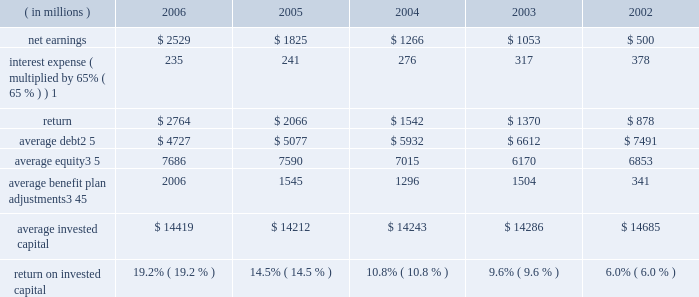Notes to five year summary ( a ) includes the effects of items not considered in the assessment of the operating performance of our business segments ( see the section , 201cresults of operations 2013 unallocated corporate ( expense ) income , net 201d in management 2019s discussion and analysis of financial condition and results of operations ( md&a ) ) which , on a combined basis , increased earnings from continuing operations before income taxes by $ 214 million , $ 139 million after tax ( $ 0.31 per share ) .
Also includes a reduction in income tax expense of $ 62 million ( $ 0.14 per share ) resulting from a tax benefit related to claims we filed for additional extraterritorial income exclusion ( eti ) tax benefits .
These items increased earnings by $ 201 million after tax ( $ 0.45 per share ) .
( b ) includes the effects of items not considered in the assessment of the operating performance of our business segments ( see the section , 201cresults of operations 2013 unallocated corporate ( expense ) income , net 201d in md&a ) which , on a combined basis , increased earnings from continuing operations before income taxes by $ 173 million , $ 113 million after tax ( $ 0.25 per share ) .
( c ) includes the effects of items not considered in the assessment of the operating performance of our business segments ( see the section , 201cresults of operations 2013 unallocated corporate ( expense ) income , net 201d in md&a ) which , on a combined basis , decreased earnings from continuing operations before income taxes by $ 215 million , $ 154 million after tax ( $ 0.34 per share ) .
Also includes a reduction in income tax expense resulting from the closure of an internal revenue service examination of $ 144 million ( $ 0.32 per share ) .
These items reduced earnings by $ 10 million after tax ( $ 0.02 per share ) .
( d ) includes the effects of items not considered in the assessment of the operating performance of our business segments which , on a combined basis , decreased earnings from continuing operations before income taxes by $ 153 million , $ 102 million after tax ( $ 0.22 per share ) .
( e ) includes the effects of items not considered in the assessment of the operating performance of our business segments which , on a combined basis , decreased earnings from continuing operations before income taxes by $ 1112 million , $ 632 million after tax ( $ 1.40 per share ) .
( f ) we define return on invested capital ( roic ) as net earnings plus after-tax interest expense divided by average invested capital ( stockholders 2019 equity plus debt ) , after adjusting stockholders 2019 equity by adding back adjustments related to postretirement benefit plans .
We believe that reporting roic provides investors with greater visibility into how effectively we use the capital invested in our operations .
We use roic to evaluate multi-year investment decisions and as a long-term performance measure , and also use it as a factor in evaluating management performance under certain of our incentive compensation plans .
Roic is not a measure of financial performance under gaap , and may not be defined and calculated by other companies in the same manner .
Roic should not be considered in isolation or as an alternative to net earnings as an indicator of performance .
We calculate roic as follows : ( in millions ) 2006 2005 2004 2003 2002 .
1 represents after-tax interest expense utilizing the federal statutory rate of 35% ( 35 % ) .
2 debt consists of long-term debt , including current maturities , and short-term borrowings ( if any ) .
3 equity includes non-cash adjustments , primarily for the additional minimum pension liability in all years and the adoption of fas 158 in 2006 .
4 average benefit plan adjustments reflect the cumulative value of entries identified in our statement of stockholders equity under the captions 201cadjustment for adoption of fas 158 201d and 201cminimum pension liability . 201d the annual benefit plan adjustments to equity were : 2006 = ( $ 1883 ) million ; 2005 = ( $ 105 ) million ; 2004 = ( $ 285 ) million ; 2003 = $ 331 million ; and 2002 = ( $ 1537 ) million .
As these entries are recorded in the fourth quarter , the value added back to our average equity in a given year is the cumulative impact of all prior year entries plus 20% ( 20 % ) of the current year entry value .
5 yearly averages are calculated using balances at the start of the year and at the end of each quarter. .
What was the average return on invested capital from 2002 to 2006? 
Computations: table_average(return on invested capital, none)
Answer: 0.1202. Notes to five year summary ( a ) includes the effects of items not considered in the assessment of the operating performance of our business segments ( see the section , 201cresults of operations 2013 unallocated corporate ( expense ) income , net 201d in management 2019s discussion and analysis of financial condition and results of operations ( md&a ) ) which , on a combined basis , increased earnings from continuing operations before income taxes by $ 214 million , $ 139 million after tax ( $ 0.31 per share ) .
Also includes a reduction in income tax expense of $ 62 million ( $ 0.14 per share ) resulting from a tax benefit related to claims we filed for additional extraterritorial income exclusion ( eti ) tax benefits .
These items increased earnings by $ 201 million after tax ( $ 0.45 per share ) .
( b ) includes the effects of items not considered in the assessment of the operating performance of our business segments ( see the section , 201cresults of operations 2013 unallocated corporate ( expense ) income , net 201d in md&a ) which , on a combined basis , increased earnings from continuing operations before income taxes by $ 173 million , $ 113 million after tax ( $ 0.25 per share ) .
( c ) includes the effects of items not considered in the assessment of the operating performance of our business segments ( see the section , 201cresults of operations 2013 unallocated corporate ( expense ) income , net 201d in md&a ) which , on a combined basis , decreased earnings from continuing operations before income taxes by $ 215 million , $ 154 million after tax ( $ 0.34 per share ) .
Also includes a reduction in income tax expense resulting from the closure of an internal revenue service examination of $ 144 million ( $ 0.32 per share ) .
These items reduced earnings by $ 10 million after tax ( $ 0.02 per share ) .
( d ) includes the effects of items not considered in the assessment of the operating performance of our business segments which , on a combined basis , decreased earnings from continuing operations before income taxes by $ 153 million , $ 102 million after tax ( $ 0.22 per share ) .
( e ) includes the effects of items not considered in the assessment of the operating performance of our business segments which , on a combined basis , decreased earnings from continuing operations before income taxes by $ 1112 million , $ 632 million after tax ( $ 1.40 per share ) .
( f ) we define return on invested capital ( roic ) as net earnings plus after-tax interest expense divided by average invested capital ( stockholders 2019 equity plus debt ) , after adjusting stockholders 2019 equity by adding back adjustments related to postretirement benefit plans .
We believe that reporting roic provides investors with greater visibility into how effectively we use the capital invested in our operations .
We use roic to evaluate multi-year investment decisions and as a long-term performance measure , and also use it as a factor in evaluating management performance under certain of our incentive compensation plans .
Roic is not a measure of financial performance under gaap , and may not be defined and calculated by other companies in the same manner .
Roic should not be considered in isolation or as an alternative to net earnings as an indicator of performance .
We calculate roic as follows : ( in millions ) 2006 2005 2004 2003 2002 .
1 represents after-tax interest expense utilizing the federal statutory rate of 35% ( 35 % ) .
2 debt consists of long-term debt , including current maturities , and short-term borrowings ( if any ) .
3 equity includes non-cash adjustments , primarily for the additional minimum pension liability in all years and the adoption of fas 158 in 2006 .
4 average benefit plan adjustments reflect the cumulative value of entries identified in our statement of stockholders equity under the captions 201cadjustment for adoption of fas 158 201d and 201cminimum pension liability . 201d the annual benefit plan adjustments to equity were : 2006 = ( $ 1883 ) million ; 2005 = ( $ 105 ) million ; 2004 = ( $ 285 ) million ; 2003 = $ 331 million ; and 2002 = ( $ 1537 ) million .
As these entries are recorded in the fourth quarter , the value added back to our average equity in a given year is the cumulative impact of all prior year entries plus 20% ( 20 % ) of the current year entry value .
5 yearly averages are calculated using balances at the start of the year and at the end of each quarter. .
What was the percentage change in the net earnings from 2005 to 2006? 
Computations: ((2529 - 1825) / 1825)
Answer: 0.38575. Notes to five year summary ( a ) includes the effects of items not considered in the assessment of the operating performance of our business segments ( see the section , 201cresults of operations 2013 unallocated corporate ( expense ) income , net 201d in management 2019s discussion and analysis of financial condition and results of operations ( md&a ) ) which , on a combined basis , increased earnings from continuing operations before income taxes by $ 214 million , $ 139 million after tax ( $ 0.31 per share ) .
Also includes a reduction in income tax expense of $ 62 million ( $ 0.14 per share ) resulting from a tax benefit related to claims we filed for additional extraterritorial income exclusion ( eti ) tax benefits .
These items increased earnings by $ 201 million after tax ( $ 0.45 per share ) .
( b ) includes the effects of items not considered in the assessment of the operating performance of our business segments ( see the section , 201cresults of operations 2013 unallocated corporate ( expense ) income , net 201d in md&a ) which , on a combined basis , increased earnings from continuing operations before income taxes by $ 173 million , $ 113 million after tax ( $ 0.25 per share ) .
( c ) includes the effects of items not considered in the assessment of the operating performance of our business segments ( see the section , 201cresults of operations 2013 unallocated corporate ( expense ) income , net 201d in md&a ) which , on a combined basis , decreased earnings from continuing operations before income taxes by $ 215 million , $ 154 million after tax ( $ 0.34 per share ) .
Also includes a reduction in income tax expense resulting from the closure of an internal revenue service examination of $ 144 million ( $ 0.32 per share ) .
These items reduced earnings by $ 10 million after tax ( $ 0.02 per share ) .
( d ) includes the effects of items not considered in the assessment of the operating performance of our business segments which , on a combined basis , decreased earnings from continuing operations before income taxes by $ 153 million , $ 102 million after tax ( $ 0.22 per share ) .
( e ) includes the effects of items not considered in the assessment of the operating performance of our business segments which , on a combined basis , decreased earnings from continuing operations before income taxes by $ 1112 million , $ 632 million after tax ( $ 1.40 per share ) .
( f ) we define return on invested capital ( roic ) as net earnings plus after-tax interest expense divided by average invested capital ( stockholders 2019 equity plus debt ) , after adjusting stockholders 2019 equity by adding back adjustments related to postretirement benefit plans .
We believe that reporting roic provides investors with greater visibility into how effectively we use the capital invested in our operations .
We use roic to evaluate multi-year investment decisions and as a long-term performance measure , and also use it as a factor in evaluating management performance under certain of our incentive compensation plans .
Roic is not a measure of financial performance under gaap , and may not be defined and calculated by other companies in the same manner .
Roic should not be considered in isolation or as an alternative to net earnings as an indicator of performance .
We calculate roic as follows : ( in millions ) 2006 2005 2004 2003 2002 .
1 represents after-tax interest expense utilizing the federal statutory rate of 35% ( 35 % ) .
2 debt consists of long-term debt , including current maturities , and short-term borrowings ( if any ) .
3 equity includes non-cash adjustments , primarily for the additional minimum pension liability in all years and the adoption of fas 158 in 2006 .
4 average benefit plan adjustments reflect the cumulative value of entries identified in our statement of stockholders equity under the captions 201cadjustment for adoption of fas 158 201d and 201cminimum pension liability . 201d the annual benefit plan adjustments to equity were : 2006 = ( $ 1883 ) million ; 2005 = ( $ 105 ) million ; 2004 = ( $ 285 ) million ; 2003 = $ 331 million ; and 2002 = ( $ 1537 ) million .
As these entries are recorded in the fourth quarter , the value added back to our average equity in a given year is the cumulative impact of all prior year entries plus 20% ( 20 % ) of the current year entry value .
5 yearly averages are calculated using balances at the start of the year and at the end of each quarter. .
What was the average net earnings in millions from 2002 to 2006? 
Computations: table_average(net earnings, none)
Answer: 1434.6. 